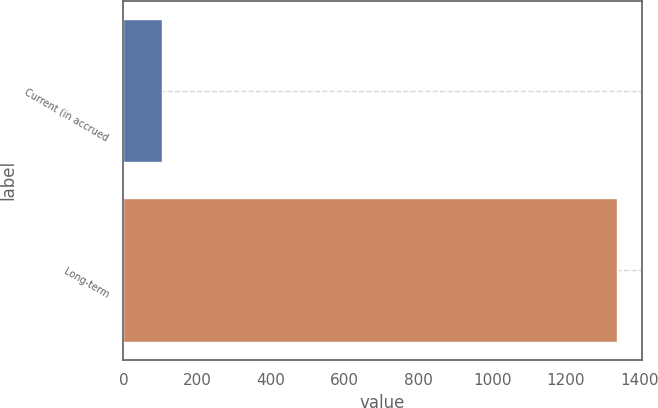Convert chart. <chart><loc_0><loc_0><loc_500><loc_500><bar_chart><fcel>Current (in accrued<fcel>Long-term<nl><fcel>104<fcel>1339<nl></chart> 